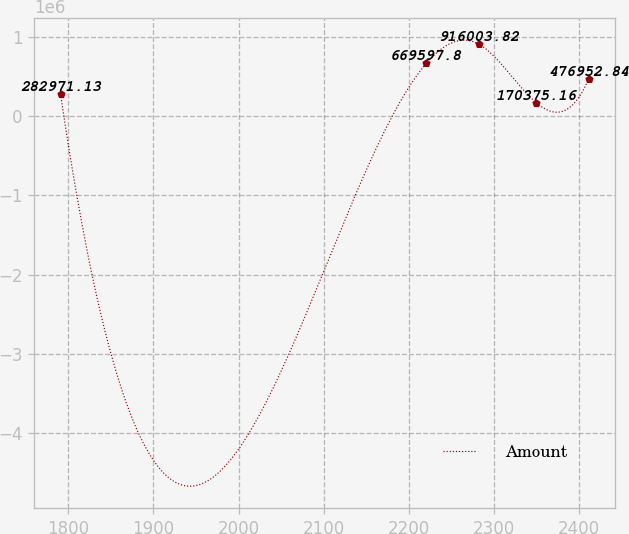<chart> <loc_0><loc_0><loc_500><loc_500><line_chart><ecel><fcel>Amount<nl><fcel>1790.93<fcel>282971<nl><fcel>2220.36<fcel>669598<nl><fcel>2281.79<fcel>916004<nl><fcel>2349.88<fcel>170375<nl><fcel>2411.31<fcel>476953<nl></chart> 